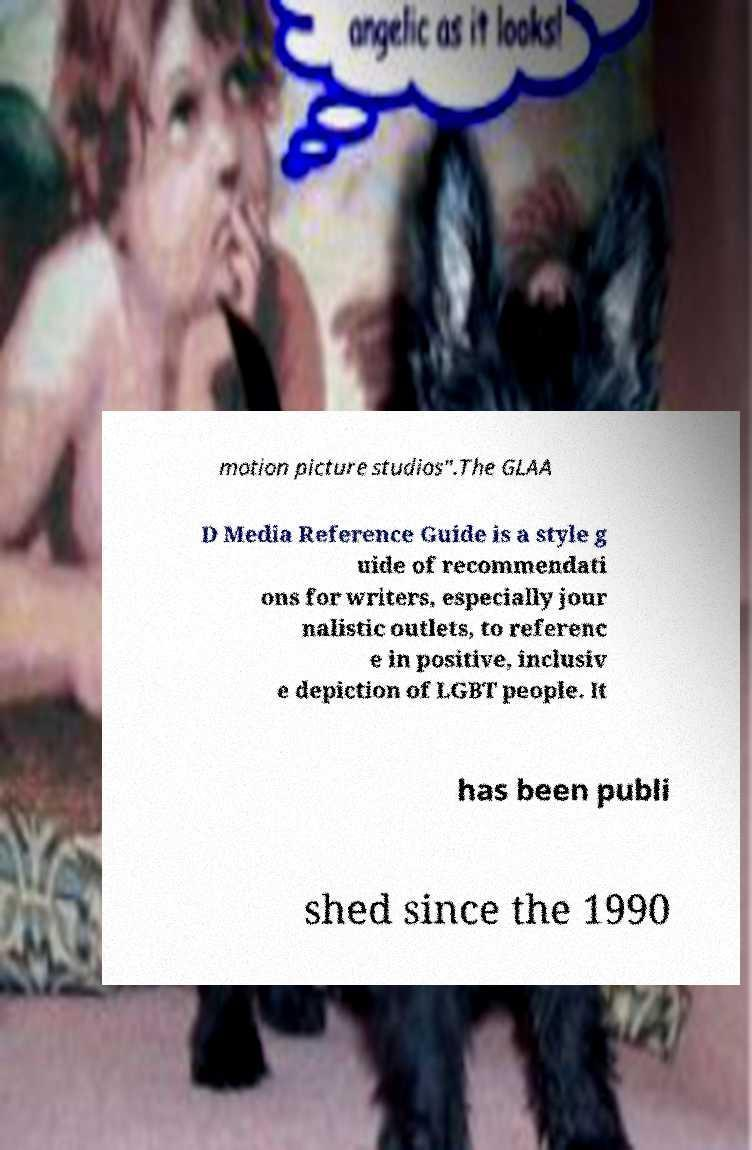What messages or text are displayed in this image? I need them in a readable, typed format. motion picture studios".The GLAA D Media Reference Guide is a style g uide of recommendati ons for writers, especially jour nalistic outlets, to referenc e in positive, inclusiv e depiction of LGBT people. It has been publi shed since the 1990 